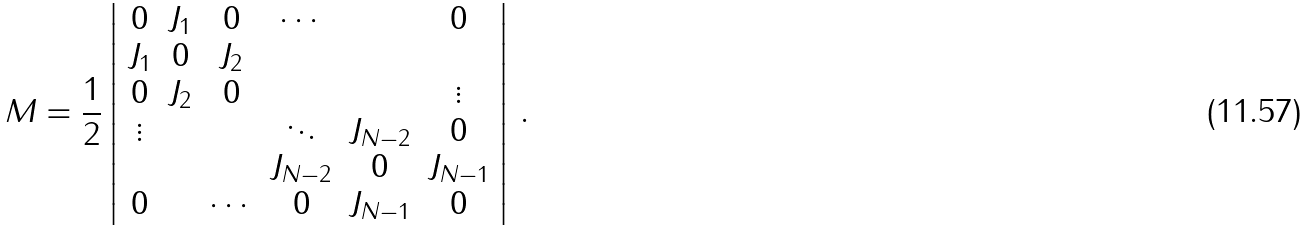Convert formula to latex. <formula><loc_0><loc_0><loc_500><loc_500>M = \frac { 1 } { 2 } \left | \begin{array} { c c c c c c } 0 & J _ { 1 } & 0 & \cdots & & 0 \\ J _ { 1 } & 0 & J _ { 2 } \\ 0 & J _ { 2 } & 0 & & & \vdots \\ \vdots & & & \ddots & J _ { N - 2 } & 0 \\ & & & J _ { N - 2 } & 0 & J _ { N - 1 } \\ 0 & & \cdots & 0 & J _ { N - 1 } & 0 \end{array} \right | \, .</formula> 